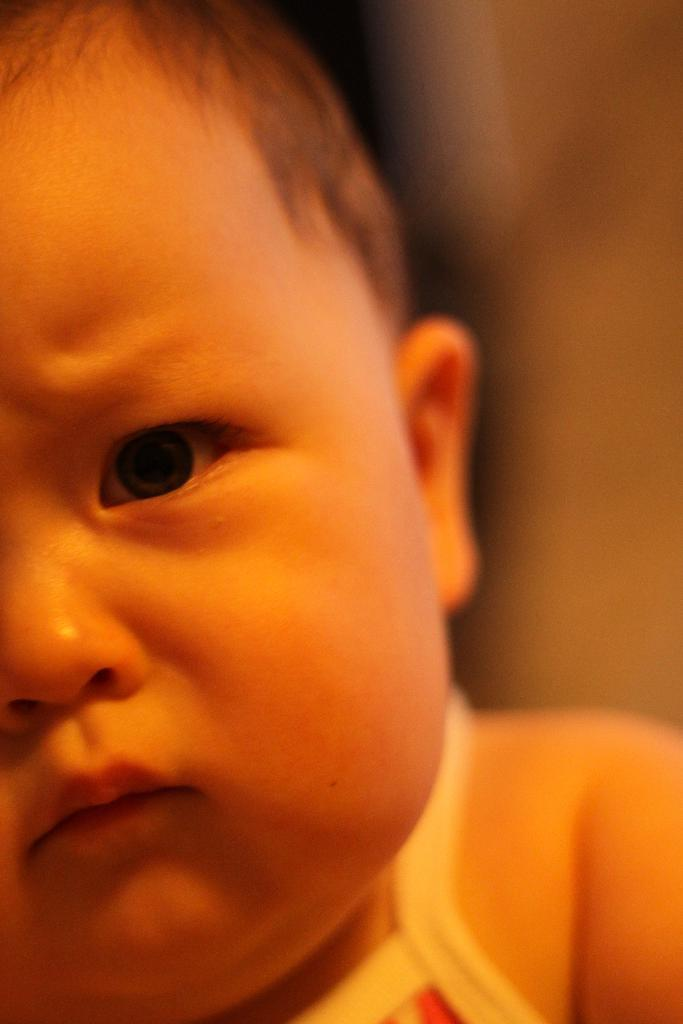What is the main subject of the image? The main subject of the image is a baby. What can be seen on the baby in the image? The baby is wearing clothes. How is the background of the image depicted? The background of the image is blurred. What type of agreement can be seen in the image? There is no agreement present in the image; it features a close-up of a baby wearing clothes with a blurred background. 